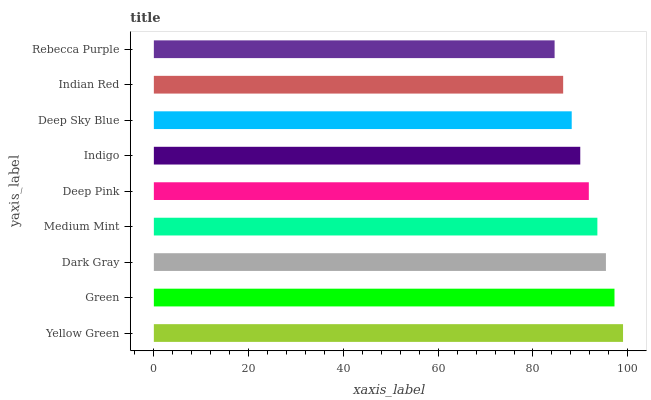Is Rebecca Purple the minimum?
Answer yes or no. Yes. Is Yellow Green the maximum?
Answer yes or no. Yes. Is Green the minimum?
Answer yes or no. No. Is Green the maximum?
Answer yes or no. No. Is Yellow Green greater than Green?
Answer yes or no. Yes. Is Green less than Yellow Green?
Answer yes or no. Yes. Is Green greater than Yellow Green?
Answer yes or no. No. Is Yellow Green less than Green?
Answer yes or no. No. Is Deep Pink the high median?
Answer yes or no. Yes. Is Deep Pink the low median?
Answer yes or no. Yes. Is Indigo the high median?
Answer yes or no. No. Is Medium Mint the low median?
Answer yes or no. No. 